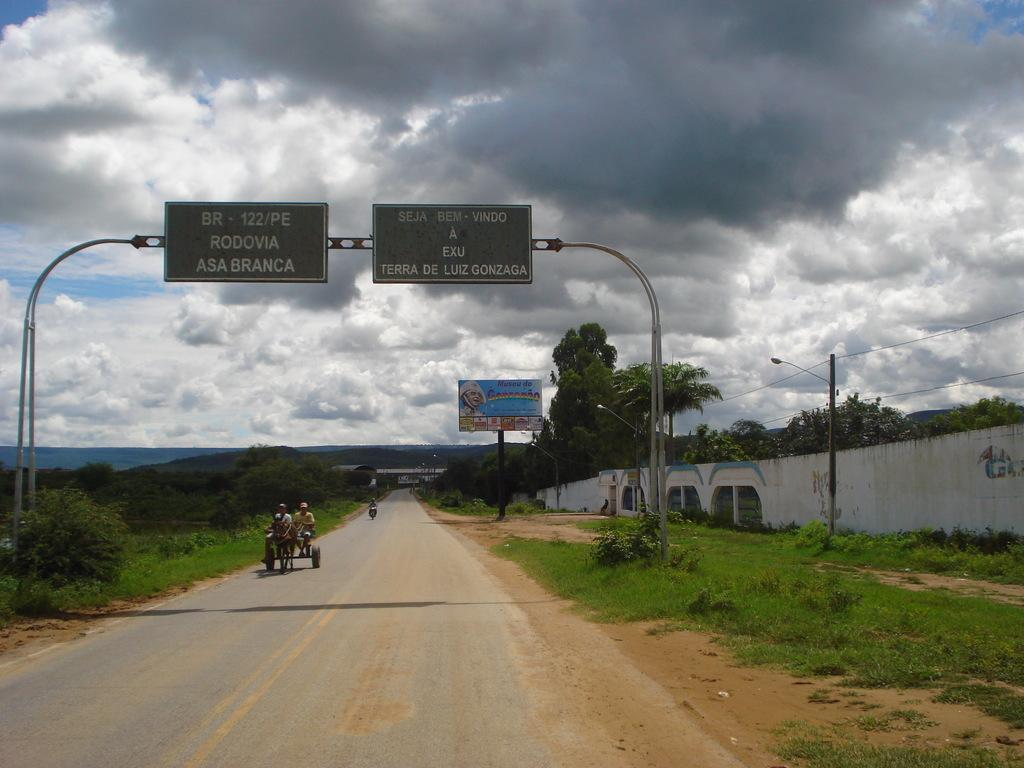<image>
Summarize the visual content of the image. Apparently Rodovia and Asa Branca are located on or near BR-122/PE. 